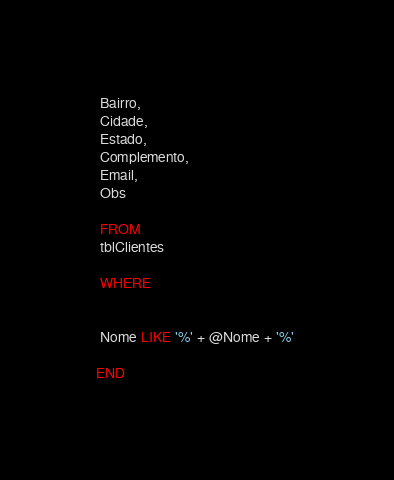Convert code to text. <code><loc_0><loc_0><loc_500><loc_500><_SQL_> Bairro,
 Cidade,
 Estado,
 Complemento,
 Email,
 Obs

 FROM 
 tblClientes
  
 WHERE 


 Nome LIKE '%' + @Nome + '%' 

END












































</code> 